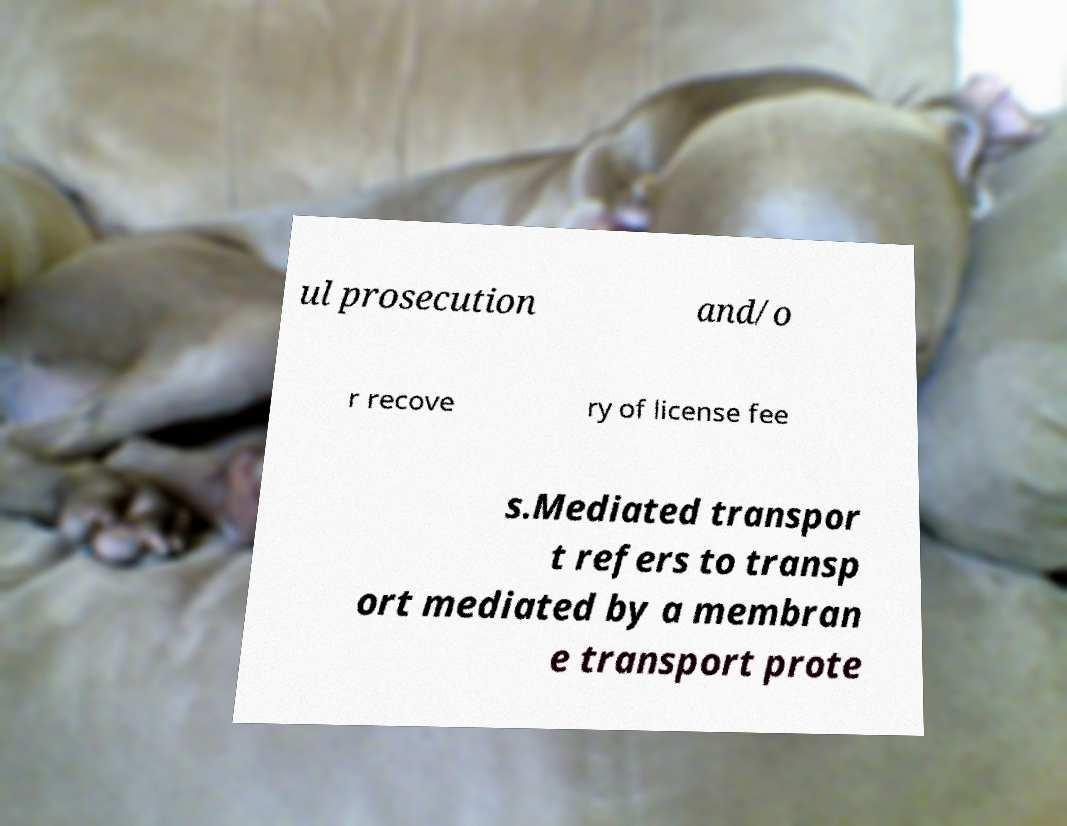Could you extract and type out the text from this image? ul prosecution and/o r recove ry of license fee s.Mediated transpor t refers to transp ort mediated by a membran e transport prote 